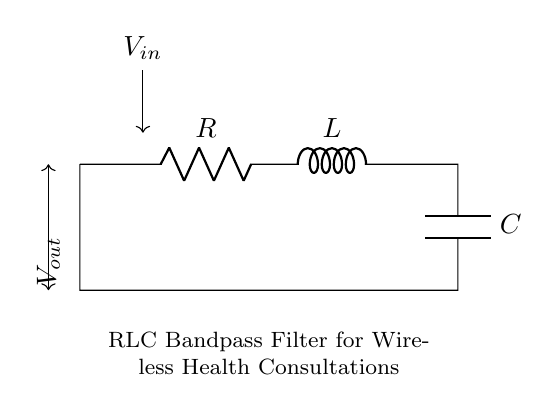What are the components present in the circuit? The main components in this circuit are a resistor, an inductor, and a capacitor, as indicated by the labels R, L, and C in the diagram.
Answer: resistor, inductor, capacitor What is the function of the RLC circuit? The function of the RLC circuit is to filter signals, specifically by allowing a certain range of frequencies to pass while attenuating others, useful for wireless communication devices in health consultations.
Answer: bandpass filter How are the components connected in the circuit? The components are connected in series between the input voltage, labeled V in, and the output voltage, labeled V out, with the capacitor being connected to ground, forming a closed loop.
Answer: in series What is the output voltage source in the circuit? The output voltage source, labeled V out, is connected between the junction of the resistor and inductor, and the capacitor connected to ground, indicating the filtered voltage output.
Answer: V out What is the role of the inductor in this circuit? The inductor stores energy in a magnetic field and provides a frequency-dependent reactance, which plays a critical role in determining the filter's characteristics in the presence of alternating current.
Answer: frequency-dependent reactance What type of response does this RLC bandpass filter exhibit? The response exhibited by this RLC bandpass filter is characterized by a peak at a specific resonant frequency, allowing signals at that frequency to pass through effectively while filtering out others.
Answer: resonant peak What happens to the signal above or below the resonant frequency? Signals above or below the resonant frequency are attenuated, meaning their amplitude is reduced significantly, making it less effective for communication at those frequencies.
Answer: attenuated 